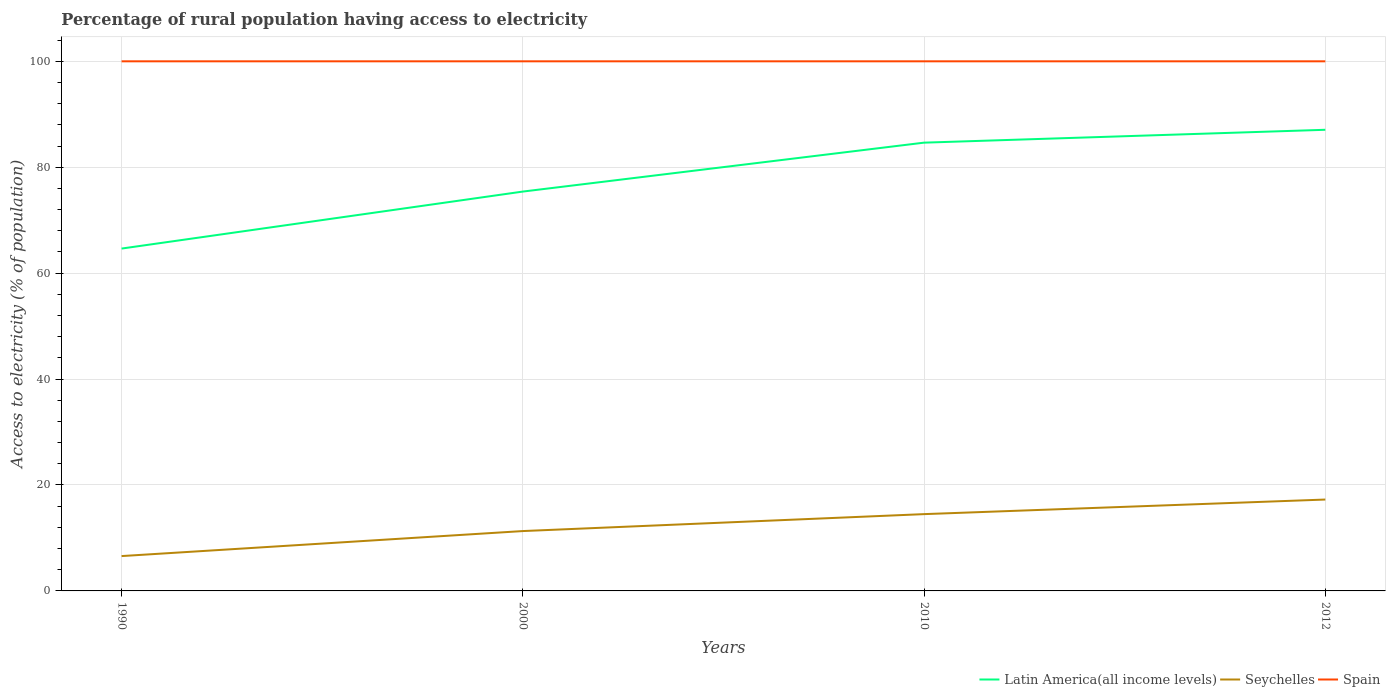Across all years, what is the maximum percentage of rural population having access to electricity in Spain?
Ensure brevity in your answer.  100. In which year was the percentage of rural population having access to electricity in Seychelles maximum?
Provide a short and direct response. 1990. What is the total percentage of rural population having access to electricity in Seychelles in the graph?
Keep it short and to the point. -7.92. What is the difference between the highest and the second highest percentage of rural population having access to electricity in Seychelles?
Provide a short and direct response. 10.68. Is the percentage of rural population having access to electricity in Latin America(all income levels) strictly greater than the percentage of rural population having access to electricity in Seychelles over the years?
Make the answer very short. No. Where does the legend appear in the graph?
Keep it short and to the point. Bottom right. How many legend labels are there?
Ensure brevity in your answer.  3. How are the legend labels stacked?
Offer a very short reply. Horizontal. What is the title of the graph?
Keep it short and to the point. Percentage of rural population having access to electricity. What is the label or title of the X-axis?
Give a very brief answer. Years. What is the label or title of the Y-axis?
Ensure brevity in your answer.  Access to electricity (% of population). What is the Access to electricity (% of population) in Latin America(all income levels) in 1990?
Provide a short and direct response. 64.64. What is the Access to electricity (% of population) in Seychelles in 1990?
Your answer should be compact. 6.58. What is the Access to electricity (% of population) of Spain in 1990?
Your answer should be very brief. 100. What is the Access to electricity (% of population) of Latin America(all income levels) in 2000?
Provide a short and direct response. 75.4. What is the Access to electricity (% of population) in Seychelles in 2000?
Make the answer very short. 11.3. What is the Access to electricity (% of population) of Latin America(all income levels) in 2010?
Offer a terse response. 84.64. What is the Access to electricity (% of population) in Latin America(all income levels) in 2012?
Make the answer very short. 87.07. What is the Access to electricity (% of population) of Seychelles in 2012?
Provide a succinct answer. 17.25. Across all years, what is the maximum Access to electricity (% of population) of Latin America(all income levels)?
Make the answer very short. 87.07. Across all years, what is the maximum Access to electricity (% of population) in Seychelles?
Ensure brevity in your answer.  17.25. Across all years, what is the minimum Access to electricity (% of population) in Latin America(all income levels)?
Keep it short and to the point. 64.64. Across all years, what is the minimum Access to electricity (% of population) of Seychelles?
Your response must be concise. 6.58. Across all years, what is the minimum Access to electricity (% of population) in Spain?
Provide a succinct answer. 100. What is the total Access to electricity (% of population) of Latin America(all income levels) in the graph?
Offer a very short reply. 311.76. What is the total Access to electricity (% of population) in Seychelles in the graph?
Make the answer very short. 49.64. What is the total Access to electricity (% of population) in Spain in the graph?
Provide a succinct answer. 400. What is the difference between the Access to electricity (% of population) in Latin America(all income levels) in 1990 and that in 2000?
Offer a very short reply. -10.76. What is the difference between the Access to electricity (% of population) of Seychelles in 1990 and that in 2000?
Your answer should be very brief. -4.72. What is the difference between the Access to electricity (% of population) of Latin America(all income levels) in 1990 and that in 2010?
Provide a short and direct response. -20. What is the difference between the Access to electricity (% of population) of Seychelles in 1990 and that in 2010?
Your answer should be very brief. -7.92. What is the difference between the Access to electricity (% of population) of Spain in 1990 and that in 2010?
Give a very brief answer. 0. What is the difference between the Access to electricity (% of population) of Latin America(all income levels) in 1990 and that in 2012?
Make the answer very short. -22.43. What is the difference between the Access to electricity (% of population) of Seychelles in 1990 and that in 2012?
Provide a succinct answer. -10.68. What is the difference between the Access to electricity (% of population) in Latin America(all income levels) in 2000 and that in 2010?
Your answer should be compact. -9.24. What is the difference between the Access to electricity (% of population) in Seychelles in 2000 and that in 2010?
Provide a succinct answer. -3.2. What is the difference between the Access to electricity (% of population) of Spain in 2000 and that in 2010?
Provide a short and direct response. 0. What is the difference between the Access to electricity (% of population) in Latin America(all income levels) in 2000 and that in 2012?
Provide a short and direct response. -11.67. What is the difference between the Access to electricity (% of population) in Seychelles in 2000 and that in 2012?
Give a very brief answer. -5.95. What is the difference between the Access to electricity (% of population) in Spain in 2000 and that in 2012?
Offer a very short reply. 0. What is the difference between the Access to electricity (% of population) in Latin America(all income levels) in 2010 and that in 2012?
Keep it short and to the point. -2.43. What is the difference between the Access to electricity (% of population) in Seychelles in 2010 and that in 2012?
Offer a very short reply. -2.75. What is the difference between the Access to electricity (% of population) of Latin America(all income levels) in 1990 and the Access to electricity (% of population) of Seychelles in 2000?
Offer a very short reply. 53.34. What is the difference between the Access to electricity (% of population) of Latin America(all income levels) in 1990 and the Access to electricity (% of population) of Spain in 2000?
Make the answer very short. -35.36. What is the difference between the Access to electricity (% of population) in Seychelles in 1990 and the Access to electricity (% of population) in Spain in 2000?
Ensure brevity in your answer.  -93.42. What is the difference between the Access to electricity (% of population) in Latin America(all income levels) in 1990 and the Access to electricity (% of population) in Seychelles in 2010?
Ensure brevity in your answer.  50.14. What is the difference between the Access to electricity (% of population) in Latin America(all income levels) in 1990 and the Access to electricity (% of population) in Spain in 2010?
Provide a succinct answer. -35.36. What is the difference between the Access to electricity (% of population) in Seychelles in 1990 and the Access to electricity (% of population) in Spain in 2010?
Ensure brevity in your answer.  -93.42. What is the difference between the Access to electricity (% of population) in Latin America(all income levels) in 1990 and the Access to electricity (% of population) in Seychelles in 2012?
Your answer should be compact. 47.39. What is the difference between the Access to electricity (% of population) in Latin America(all income levels) in 1990 and the Access to electricity (% of population) in Spain in 2012?
Offer a very short reply. -35.36. What is the difference between the Access to electricity (% of population) of Seychelles in 1990 and the Access to electricity (% of population) of Spain in 2012?
Your response must be concise. -93.42. What is the difference between the Access to electricity (% of population) in Latin America(all income levels) in 2000 and the Access to electricity (% of population) in Seychelles in 2010?
Offer a terse response. 60.9. What is the difference between the Access to electricity (% of population) of Latin America(all income levels) in 2000 and the Access to electricity (% of population) of Spain in 2010?
Ensure brevity in your answer.  -24.6. What is the difference between the Access to electricity (% of population) in Seychelles in 2000 and the Access to electricity (% of population) in Spain in 2010?
Offer a very short reply. -88.7. What is the difference between the Access to electricity (% of population) in Latin America(all income levels) in 2000 and the Access to electricity (% of population) in Seychelles in 2012?
Offer a terse response. 58.15. What is the difference between the Access to electricity (% of population) in Latin America(all income levels) in 2000 and the Access to electricity (% of population) in Spain in 2012?
Ensure brevity in your answer.  -24.6. What is the difference between the Access to electricity (% of population) of Seychelles in 2000 and the Access to electricity (% of population) of Spain in 2012?
Give a very brief answer. -88.7. What is the difference between the Access to electricity (% of population) of Latin America(all income levels) in 2010 and the Access to electricity (% of population) of Seychelles in 2012?
Offer a terse response. 67.39. What is the difference between the Access to electricity (% of population) of Latin America(all income levels) in 2010 and the Access to electricity (% of population) of Spain in 2012?
Give a very brief answer. -15.36. What is the difference between the Access to electricity (% of population) in Seychelles in 2010 and the Access to electricity (% of population) in Spain in 2012?
Make the answer very short. -85.5. What is the average Access to electricity (% of population) in Latin America(all income levels) per year?
Your answer should be compact. 77.94. What is the average Access to electricity (% of population) of Seychelles per year?
Give a very brief answer. 12.41. What is the average Access to electricity (% of population) in Spain per year?
Provide a succinct answer. 100. In the year 1990, what is the difference between the Access to electricity (% of population) in Latin America(all income levels) and Access to electricity (% of population) in Seychelles?
Your answer should be very brief. 58.06. In the year 1990, what is the difference between the Access to electricity (% of population) in Latin America(all income levels) and Access to electricity (% of population) in Spain?
Ensure brevity in your answer.  -35.36. In the year 1990, what is the difference between the Access to electricity (% of population) of Seychelles and Access to electricity (% of population) of Spain?
Give a very brief answer. -93.42. In the year 2000, what is the difference between the Access to electricity (% of population) in Latin America(all income levels) and Access to electricity (% of population) in Seychelles?
Provide a succinct answer. 64.1. In the year 2000, what is the difference between the Access to electricity (% of population) in Latin America(all income levels) and Access to electricity (% of population) in Spain?
Ensure brevity in your answer.  -24.6. In the year 2000, what is the difference between the Access to electricity (% of population) in Seychelles and Access to electricity (% of population) in Spain?
Provide a succinct answer. -88.7. In the year 2010, what is the difference between the Access to electricity (% of population) in Latin America(all income levels) and Access to electricity (% of population) in Seychelles?
Ensure brevity in your answer.  70.14. In the year 2010, what is the difference between the Access to electricity (% of population) in Latin America(all income levels) and Access to electricity (% of population) in Spain?
Ensure brevity in your answer.  -15.36. In the year 2010, what is the difference between the Access to electricity (% of population) of Seychelles and Access to electricity (% of population) of Spain?
Your answer should be compact. -85.5. In the year 2012, what is the difference between the Access to electricity (% of population) in Latin America(all income levels) and Access to electricity (% of population) in Seychelles?
Offer a terse response. 69.82. In the year 2012, what is the difference between the Access to electricity (% of population) of Latin America(all income levels) and Access to electricity (% of population) of Spain?
Your response must be concise. -12.93. In the year 2012, what is the difference between the Access to electricity (% of population) of Seychelles and Access to electricity (% of population) of Spain?
Make the answer very short. -82.75. What is the ratio of the Access to electricity (% of population) of Latin America(all income levels) in 1990 to that in 2000?
Your response must be concise. 0.86. What is the ratio of the Access to electricity (% of population) in Seychelles in 1990 to that in 2000?
Make the answer very short. 0.58. What is the ratio of the Access to electricity (% of population) in Spain in 1990 to that in 2000?
Ensure brevity in your answer.  1. What is the ratio of the Access to electricity (% of population) of Latin America(all income levels) in 1990 to that in 2010?
Offer a terse response. 0.76. What is the ratio of the Access to electricity (% of population) of Seychelles in 1990 to that in 2010?
Your answer should be very brief. 0.45. What is the ratio of the Access to electricity (% of population) in Spain in 1990 to that in 2010?
Your answer should be compact. 1. What is the ratio of the Access to electricity (% of population) in Latin America(all income levels) in 1990 to that in 2012?
Offer a very short reply. 0.74. What is the ratio of the Access to electricity (% of population) of Seychelles in 1990 to that in 2012?
Your answer should be very brief. 0.38. What is the ratio of the Access to electricity (% of population) in Latin America(all income levels) in 2000 to that in 2010?
Ensure brevity in your answer.  0.89. What is the ratio of the Access to electricity (% of population) of Seychelles in 2000 to that in 2010?
Keep it short and to the point. 0.78. What is the ratio of the Access to electricity (% of population) in Spain in 2000 to that in 2010?
Ensure brevity in your answer.  1. What is the ratio of the Access to electricity (% of population) in Latin America(all income levels) in 2000 to that in 2012?
Offer a very short reply. 0.87. What is the ratio of the Access to electricity (% of population) in Seychelles in 2000 to that in 2012?
Make the answer very short. 0.66. What is the ratio of the Access to electricity (% of population) of Spain in 2000 to that in 2012?
Your answer should be compact. 1. What is the ratio of the Access to electricity (% of population) in Latin America(all income levels) in 2010 to that in 2012?
Give a very brief answer. 0.97. What is the ratio of the Access to electricity (% of population) of Seychelles in 2010 to that in 2012?
Offer a terse response. 0.84. What is the difference between the highest and the second highest Access to electricity (% of population) of Latin America(all income levels)?
Keep it short and to the point. 2.43. What is the difference between the highest and the second highest Access to electricity (% of population) of Seychelles?
Give a very brief answer. 2.75. What is the difference between the highest and the lowest Access to electricity (% of population) of Latin America(all income levels)?
Offer a terse response. 22.43. What is the difference between the highest and the lowest Access to electricity (% of population) in Seychelles?
Give a very brief answer. 10.68. 